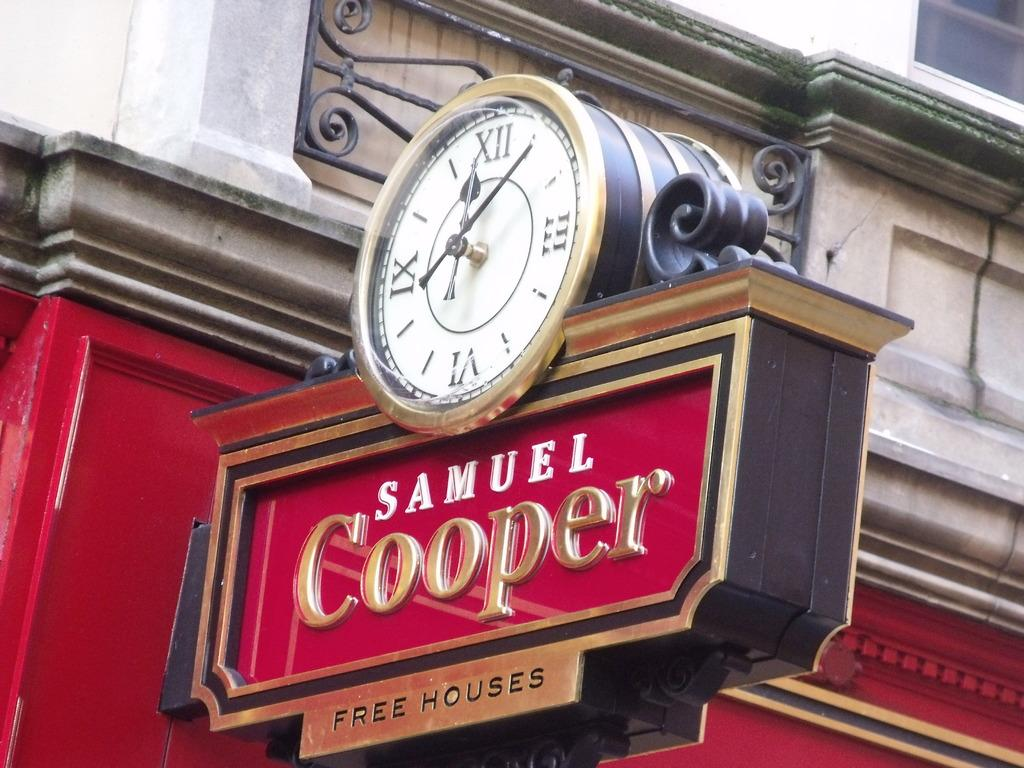Provide a one-sentence caption for the provided image. Samuel Cooper free houses sign with a clock on top. 